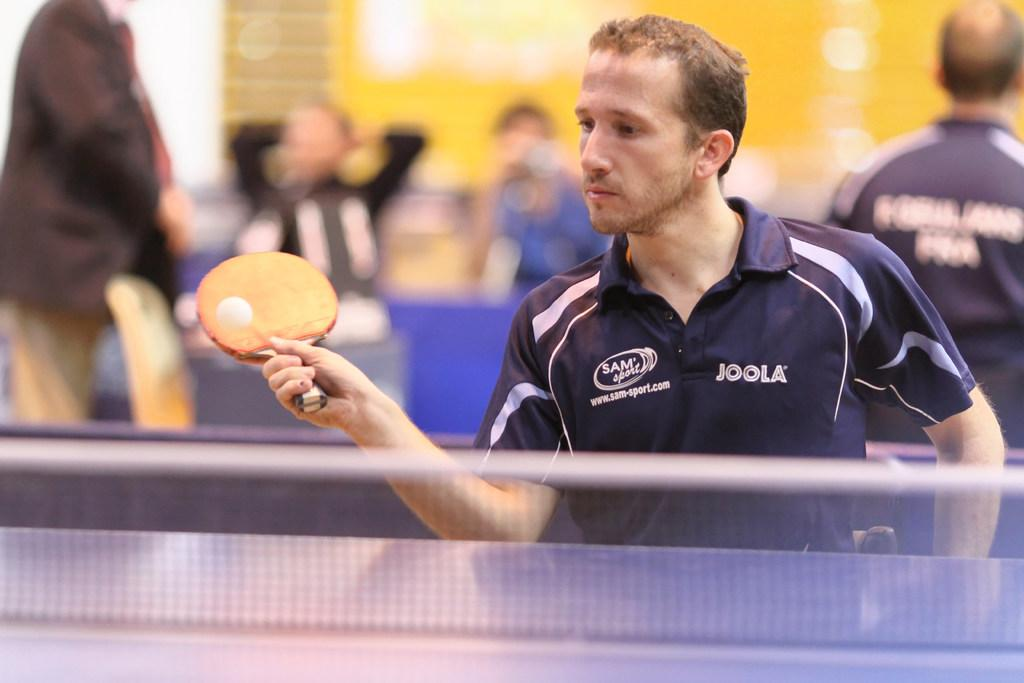Provide a one-sentence caption for the provided image. A man wearing a JOOLA shirt is playing ping pong. 